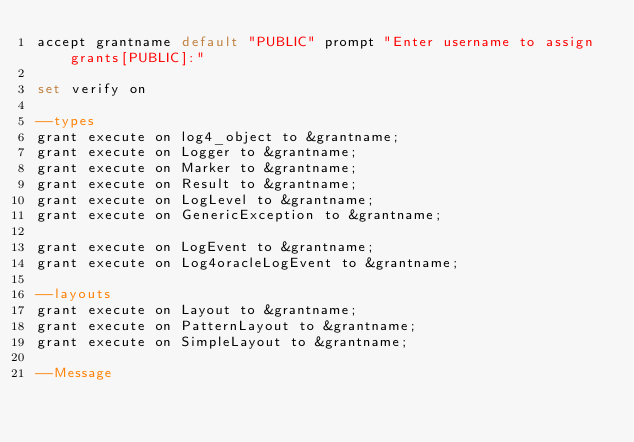Convert code to text. <code><loc_0><loc_0><loc_500><loc_500><_SQL_>accept grantname default "PUBLIC" prompt "Enter username to assign grants[PUBLIC]:"

set verify on

--types
grant execute on log4_object to &grantname;
grant execute on Logger to &grantname;
grant execute on Marker to &grantname;
grant execute on Result to &grantname;
grant execute on LogLevel to &grantname;
grant execute on GenericException to &grantname;

grant execute on LogEvent to &grantname;
grant execute on Log4oracleLogEvent to &grantname;

--layouts
grant execute on Layout to &grantname;
grant execute on PatternLayout to &grantname;
grant execute on SimpleLayout to &grantname;

--Message</code> 